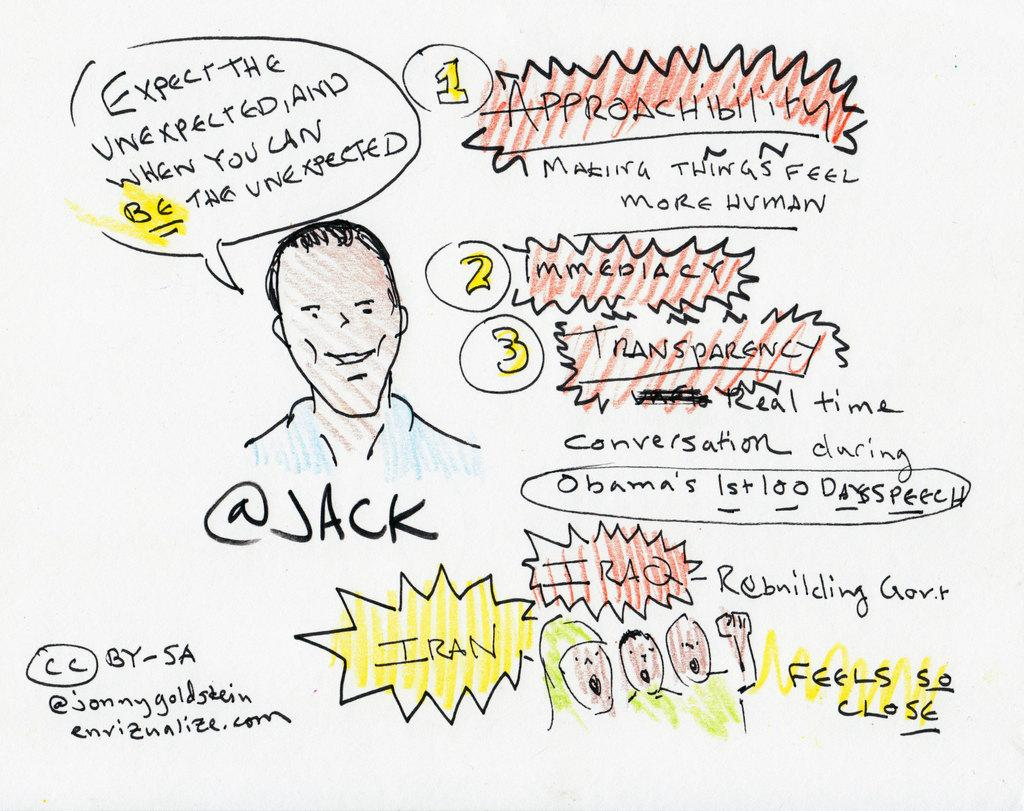What is the color of the wall in the image? The wall in the image is white. What is present on the white wall? Text is written on the wall, and there is a drawing of persons on it. What type of cord is hanging from the ceiling in the image? There is no cord hanging from the ceiling in the image; it only features a white wall with text and a drawing of persons. 